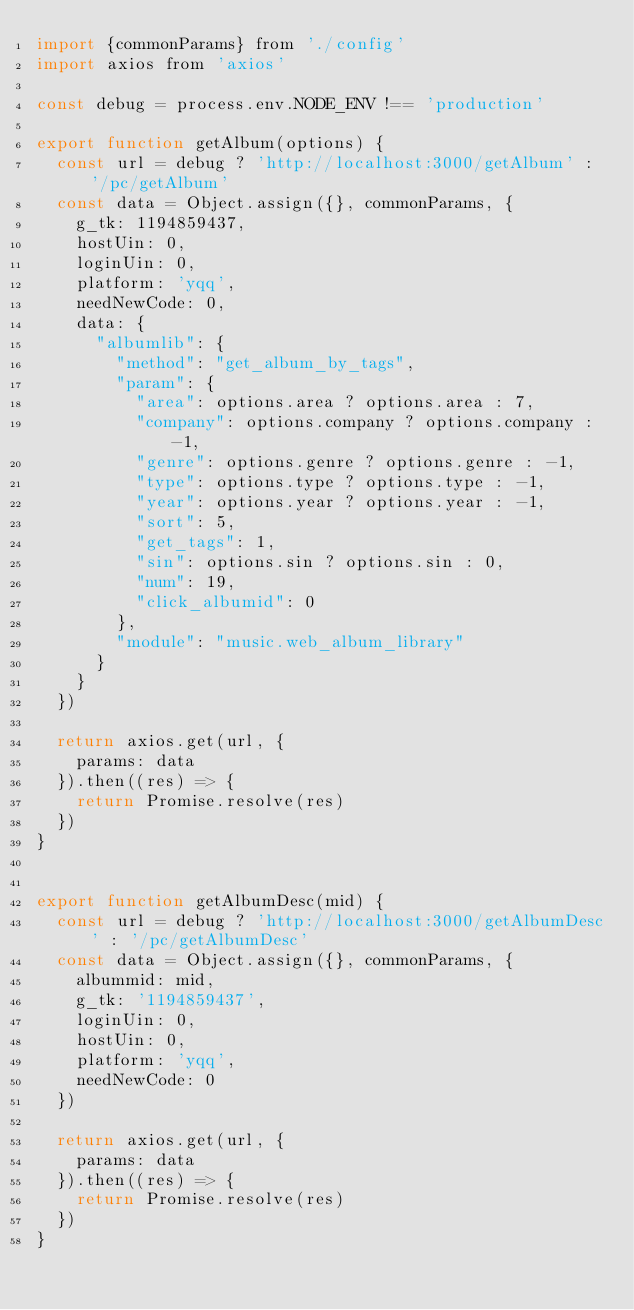<code> <loc_0><loc_0><loc_500><loc_500><_JavaScript_>import {commonParams} from './config'
import axios from 'axios'

const debug = process.env.NODE_ENV !== 'production'

export function getAlbum(options) {
  const url = debug ? 'http://localhost:3000/getAlbum' : '/pc/getAlbum'
  const data = Object.assign({}, commonParams, {
    g_tk: 1194859437,
    hostUin: 0,
    loginUin: 0,
    platform: 'yqq',
    needNewCode: 0,
    data: {
      "albumlib": {
        "method": "get_album_by_tags",
        "param": {
          "area": options.area ? options.area : 7,
          "company": options.company ? options.company : -1,
          "genre": options.genre ? options.genre : -1,
          "type": options.type ? options.type : -1,
          "year": options.year ? options.year : -1,
          "sort": 5,
          "get_tags": 1,
          "sin": options.sin ? options.sin : 0,
          "num": 19,
          "click_albumid": 0
        },
        "module": "music.web_album_library"
      }
    }
  })

  return axios.get(url, {
    params: data
  }).then((res) => {
    return Promise.resolve(res)
  })
}


export function getAlbumDesc(mid) {
  const url = debug ? 'http://localhost:3000/getAlbumDesc' : '/pc/getAlbumDesc'
  const data = Object.assign({}, commonParams, {
    albummid: mid,
    g_tk: '1194859437',
    loginUin: 0,
    hostUin: 0,
    platform: 'yqq',
    needNewCode: 0
  })

  return axios.get(url, {
    params: data
  }).then((res) => {
    return Promise.resolve(res)
  })
}



</code> 